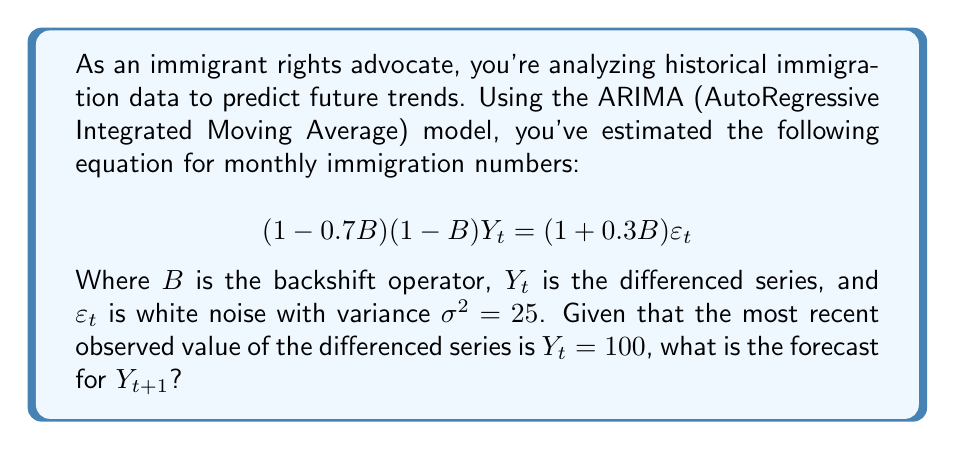Can you solve this math problem? To solve this problem, we'll follow these steps:

1) First, let's expand the ARIMA equation:
   $$(1 - 0.7B)(1 - B)Y_t = (1 + 0.3B)\varepsilon_t$$
   $(1 - B - 0.7B + 0.7B^2)Y_t = (1 + 0.3B)\varepsilon_t$
   $Y_t - Y_{t-1} - 0.7Y_{t-1} + 0.7Y_{t-2} = \varepsilon_t + 0.3\varepsilon_{t-1}$

2) Rearrange to isolate $Y_t$:
   $Y_t = Y_{t-1} + 0.7Y_{t-1} - 0.7Y_{t-2} + \varepsilon_t + 0.3\varepsilon_{t-1}$
   $Y_t = 1.7Y_{t-1} - 0.7Y_{t-2} + \varepsilon_t + 0.3\varepsilon_{t-1}$

3) To forecast $Y_{t+1}$, we replace all future (unknown) error terms with their expected value of 0:
   $E(Y_{t+1}) = 1.7Y_t - 0.7Y_{t-1} + 0 + 0$

4) We're given that $Y_t = 100$. We don't know $Y_{t-1}$, but we can estimate it:
   $Y_t = 1.7Y_{t-1} - 0.7Y_{t-2} + \varepsilon_t + 0.3\varepsilon_{t-1}$
   $100 \approx 1.7Y_{t-1} - 0.7Y_{t-1} = Y_{t-1}$ (assuming $Y_{t-1} \approx Y_{t-2}$ for simplicity)

5) Substituting into our forecast equation:
   $E(Y_{t+1}) = 1.7(100) - 0.7(100) = 170 - 70 = 100$

Therefore, the forecast for $Y_{t+1}$ is 100.
Answer: 100 